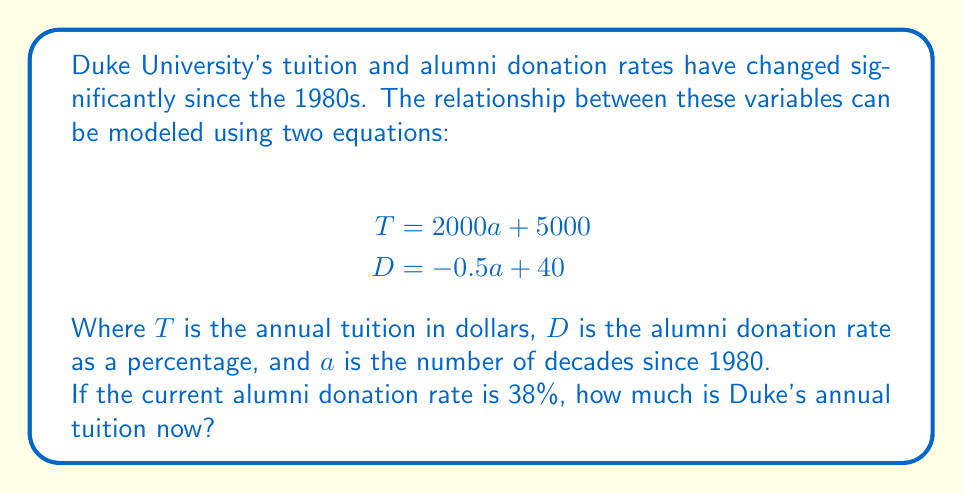Teach me how to tackle this problem. To solve this problem, we'll follow these steps:

1) First, we need to find the value of $a$ (decades since 1980) using the donation rate equation:

   $$D = -0.5a + 40$$
   $$38 = -0.5a + 40$$

2) Subtract 40 from both sides:
   $$-2 = -0.5a$$

3) Divide both sides by -0.5:
   $$a = 4$$

4) This means it's been 4 decades since 1980, which checks out as we're in the 2020s.

5) Now, we can use this value of $a$ in the tuition equation:

   $$T = 2000a + 5000$$
   $$T = 2000(4) + 5000$$

6) Simplify:
   $$T = 8000 + 5000 = 13000$$

Therefore, Duke's annual tuition is now $13,000.
Answer: $13,000 